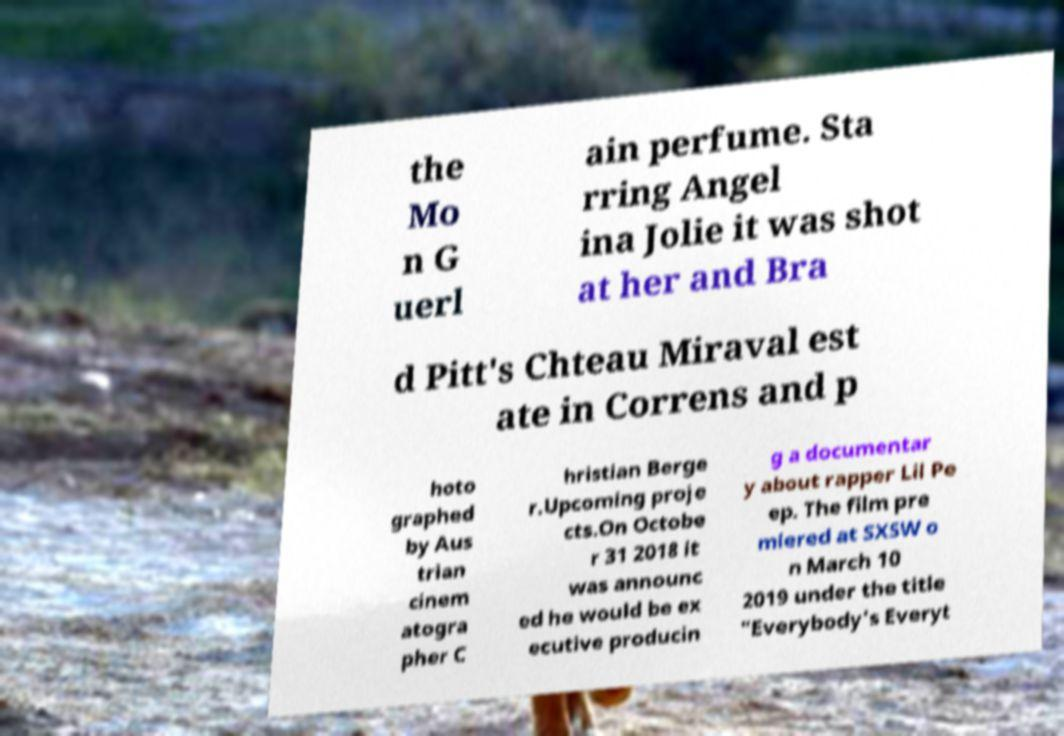Can you accurately transcribe the text from the provided image for me? the Mo n G uerl ain perfume. Sta rring Angel ina Jolie it was shot at her and Bra d Pitt's Chteau Miraval est ate in Correns and p hoto graphed by Aus trian cinem atogra pher C hristian Berge r.Upcoming proje cts.On Octobe r 31 2018 it was announc ed he would be ex ecutive producin g a documentar y about rapper Lil Pe ep. The film pre miered at SXSW o n March 10 2019 under the title "Everybody's Everyt 